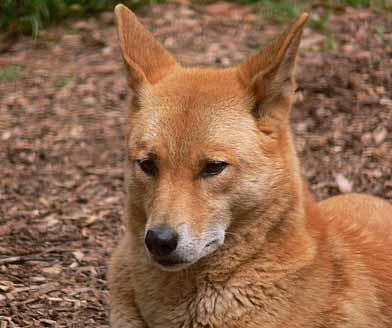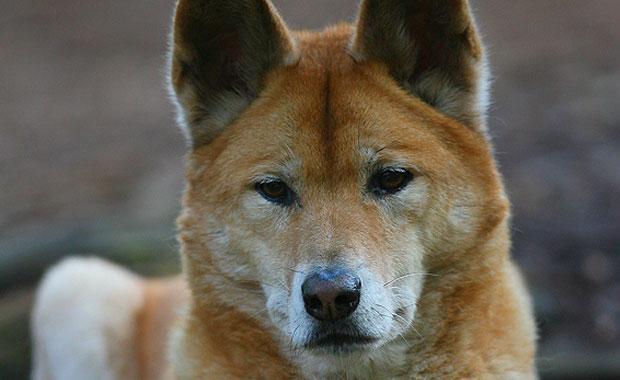The first image is the image on the left, the second image is the image on the right. Assess this claim about the two images: "In at least one image there is a single brown and white dog facing slightly right with there mouth closed.". Correct or not? Answer yes or no. Yes. 